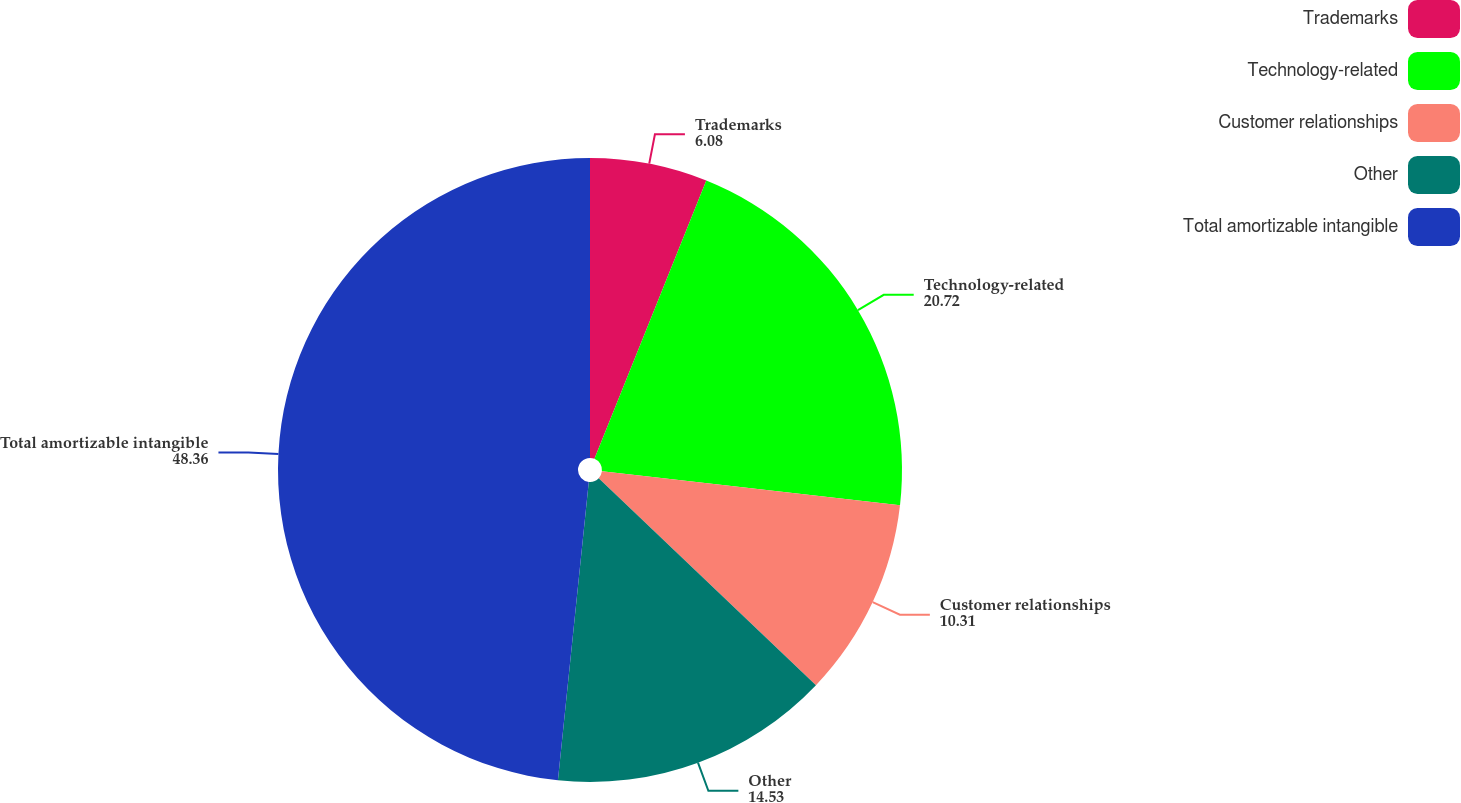Convert chart. <chart><loc_0><loc_0><loc_500><loc_500><pie_chart><fcel>Trademarks<fcel>Technology-related<fcel>Customer relationships<fcel>Other<fcel>Total amortizable intangible<nl><fcel>6.08%<fcel>20.72%<fcel>10.31%<fcel>14.53%<fcel>48.36%<nl></chart> 